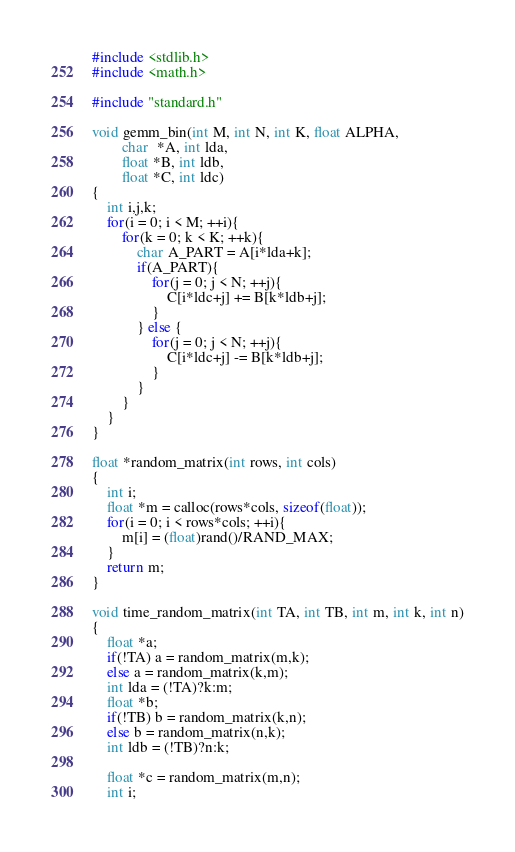<code> <loc_0><loc_0><loc_500><loc_500><_C_>#include <stdlib.h>
#include <math.h>

#include "standard.h"

void gemm_bin(int M, int N, int K, float ALPHA, 
        char  *A, int lda, 
        float *B, int ldb,
        float *C, int ldc)
{
    int i,j,k;
    for(i = 0; i < M; ++i){
        for(k = 0; k < K; ++k){
            char A_PART = A[i*lda+k];
            if(A_PART){
                for(j = 0; j < N; ++j){
                    C[i*ldc+j] += B[k*ldb+j];
                }
            } else {
                for(j = 0; j < N; ++j){
                    C[i*ldc+j] -= B[k*ldb+j];
                }
            } 
        } 
    } 
} 

float *random_matrix(int rows, int cols)
{ 
    int i; 
    float *m = calloc(rows*cols, sizeof(float));
    for(i = 0; i < rows*cols; ++i){
        m[i] = (float)rand()/RAND_MAX;
    }
    return m;
}

void time_random_matrix(int TA, int TB, int m, int k, int n)
{
    float *a;
    if(!TA) a = random_matrix(m,k);
    else a = random_matrix(k,m);
    int lda = (!TA)?k:m;
    float *b;
    if(!TB) b = random_matrix(k,n);
    else b = random_matrix(n,k);
    int ldb = (!TB)?n:k;

    float *c = random_matrix(m,n);
    int i;</code> 